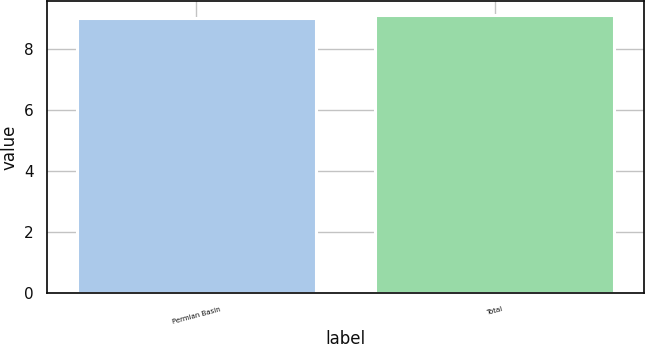Convert chart to OTSL. <chart><loc_0><loc_0><loc_500><loc_500><bar_chart><fcel>Permian Basin<fcel>Total<nl><fcel>9<fcel>9.1<nl></chart> 